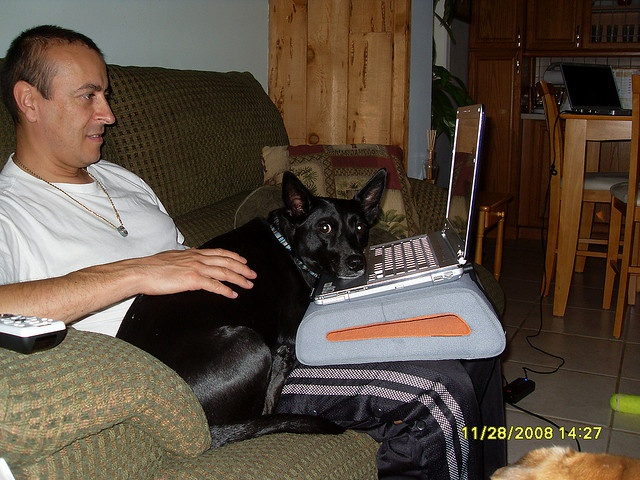Describe the objects in this image and their specific colors. I can see people in gray, black, lightgray, and darkgray tones, dog in gray, black, tan, and salmon tones, couch in gray and black tones, couch in gray and tan tones, and laptop in gray, black, maroon, and white tones in this image. 